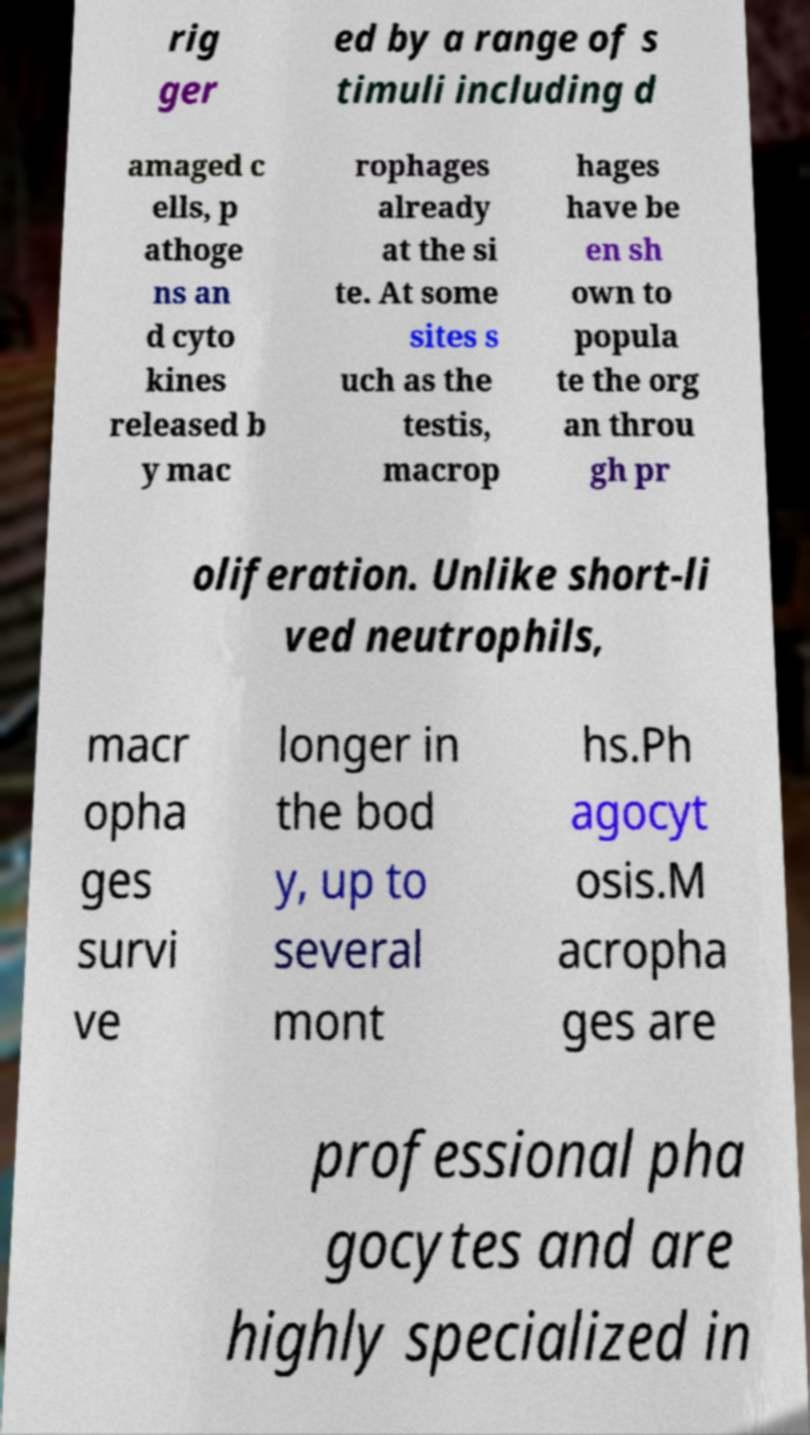There's text embedded in this image that I need extracted. Can you transcribe it verbatim? rig ger ed by a range of s timuli including d amaged c ells, p athoge ns an d cyto kines released b y mac rophages already at the si te. At some sites s uch as the testis, macrop hages have be en sh own to popula te the org an throu gh pr oliferation. Unlike short-li ved neutrophils, macr opha ges survi ve longer in the bod y, up to several mont hs.Ph agocyt osis.M acropha ges are professional pha gocytes and are highly specialized in 